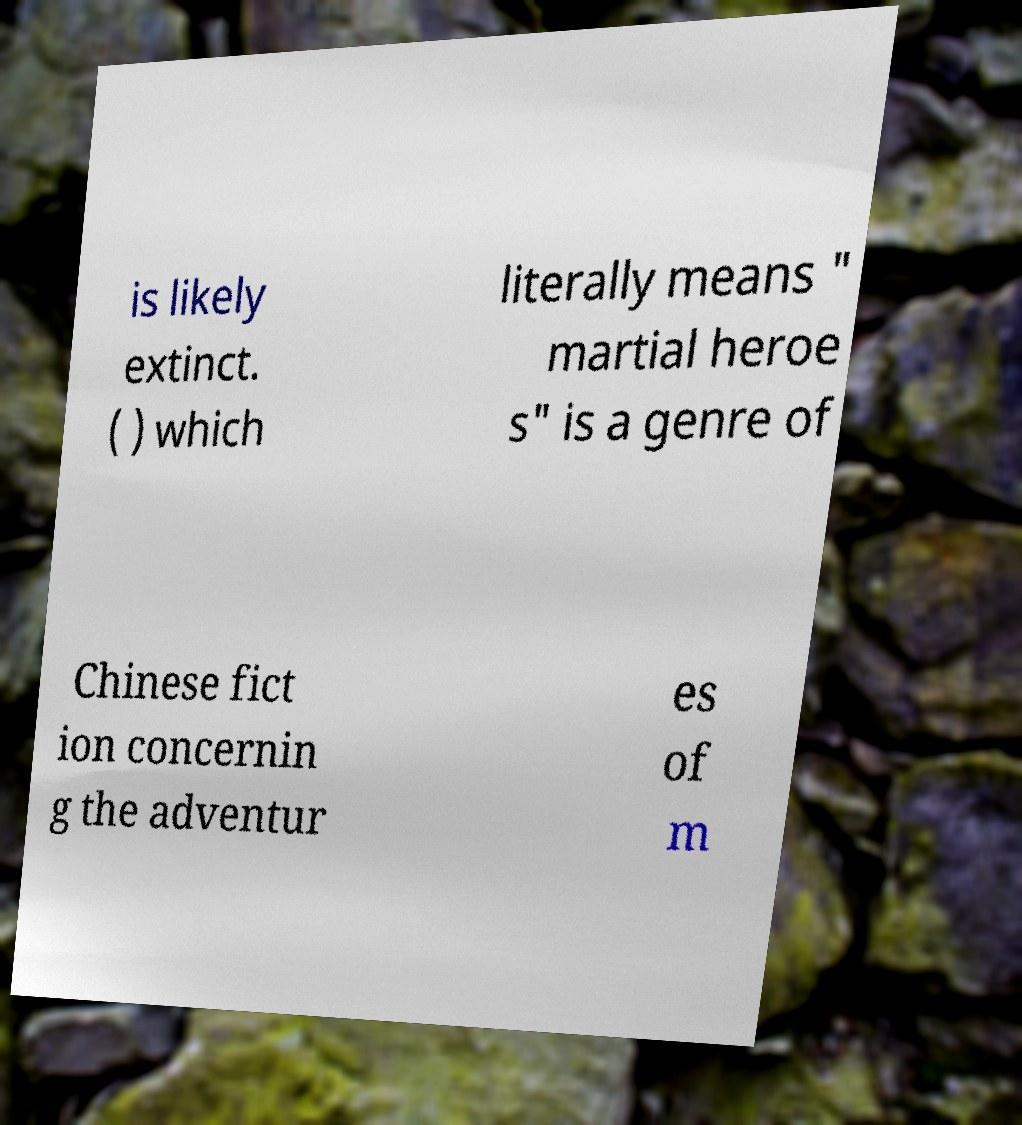What messages or text are displayed in this image? I need them in a readable, typed format. is likely extinct. ( ) which literally means " martial heroe s" is a genre of Chinese fict ion concernin g the adventur es of m 